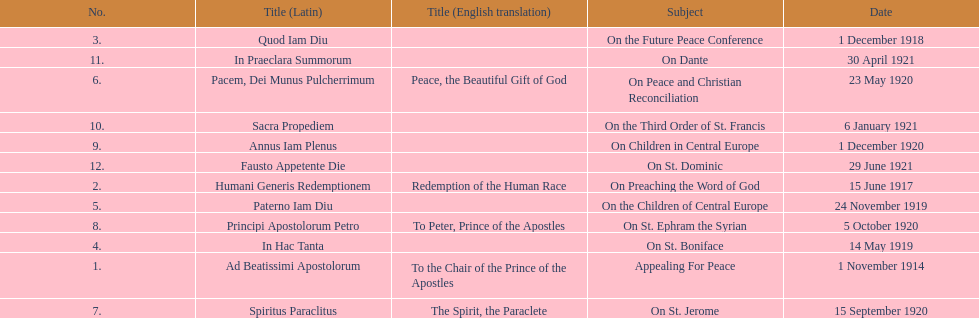What are the number of titles with a date of november? 2. 